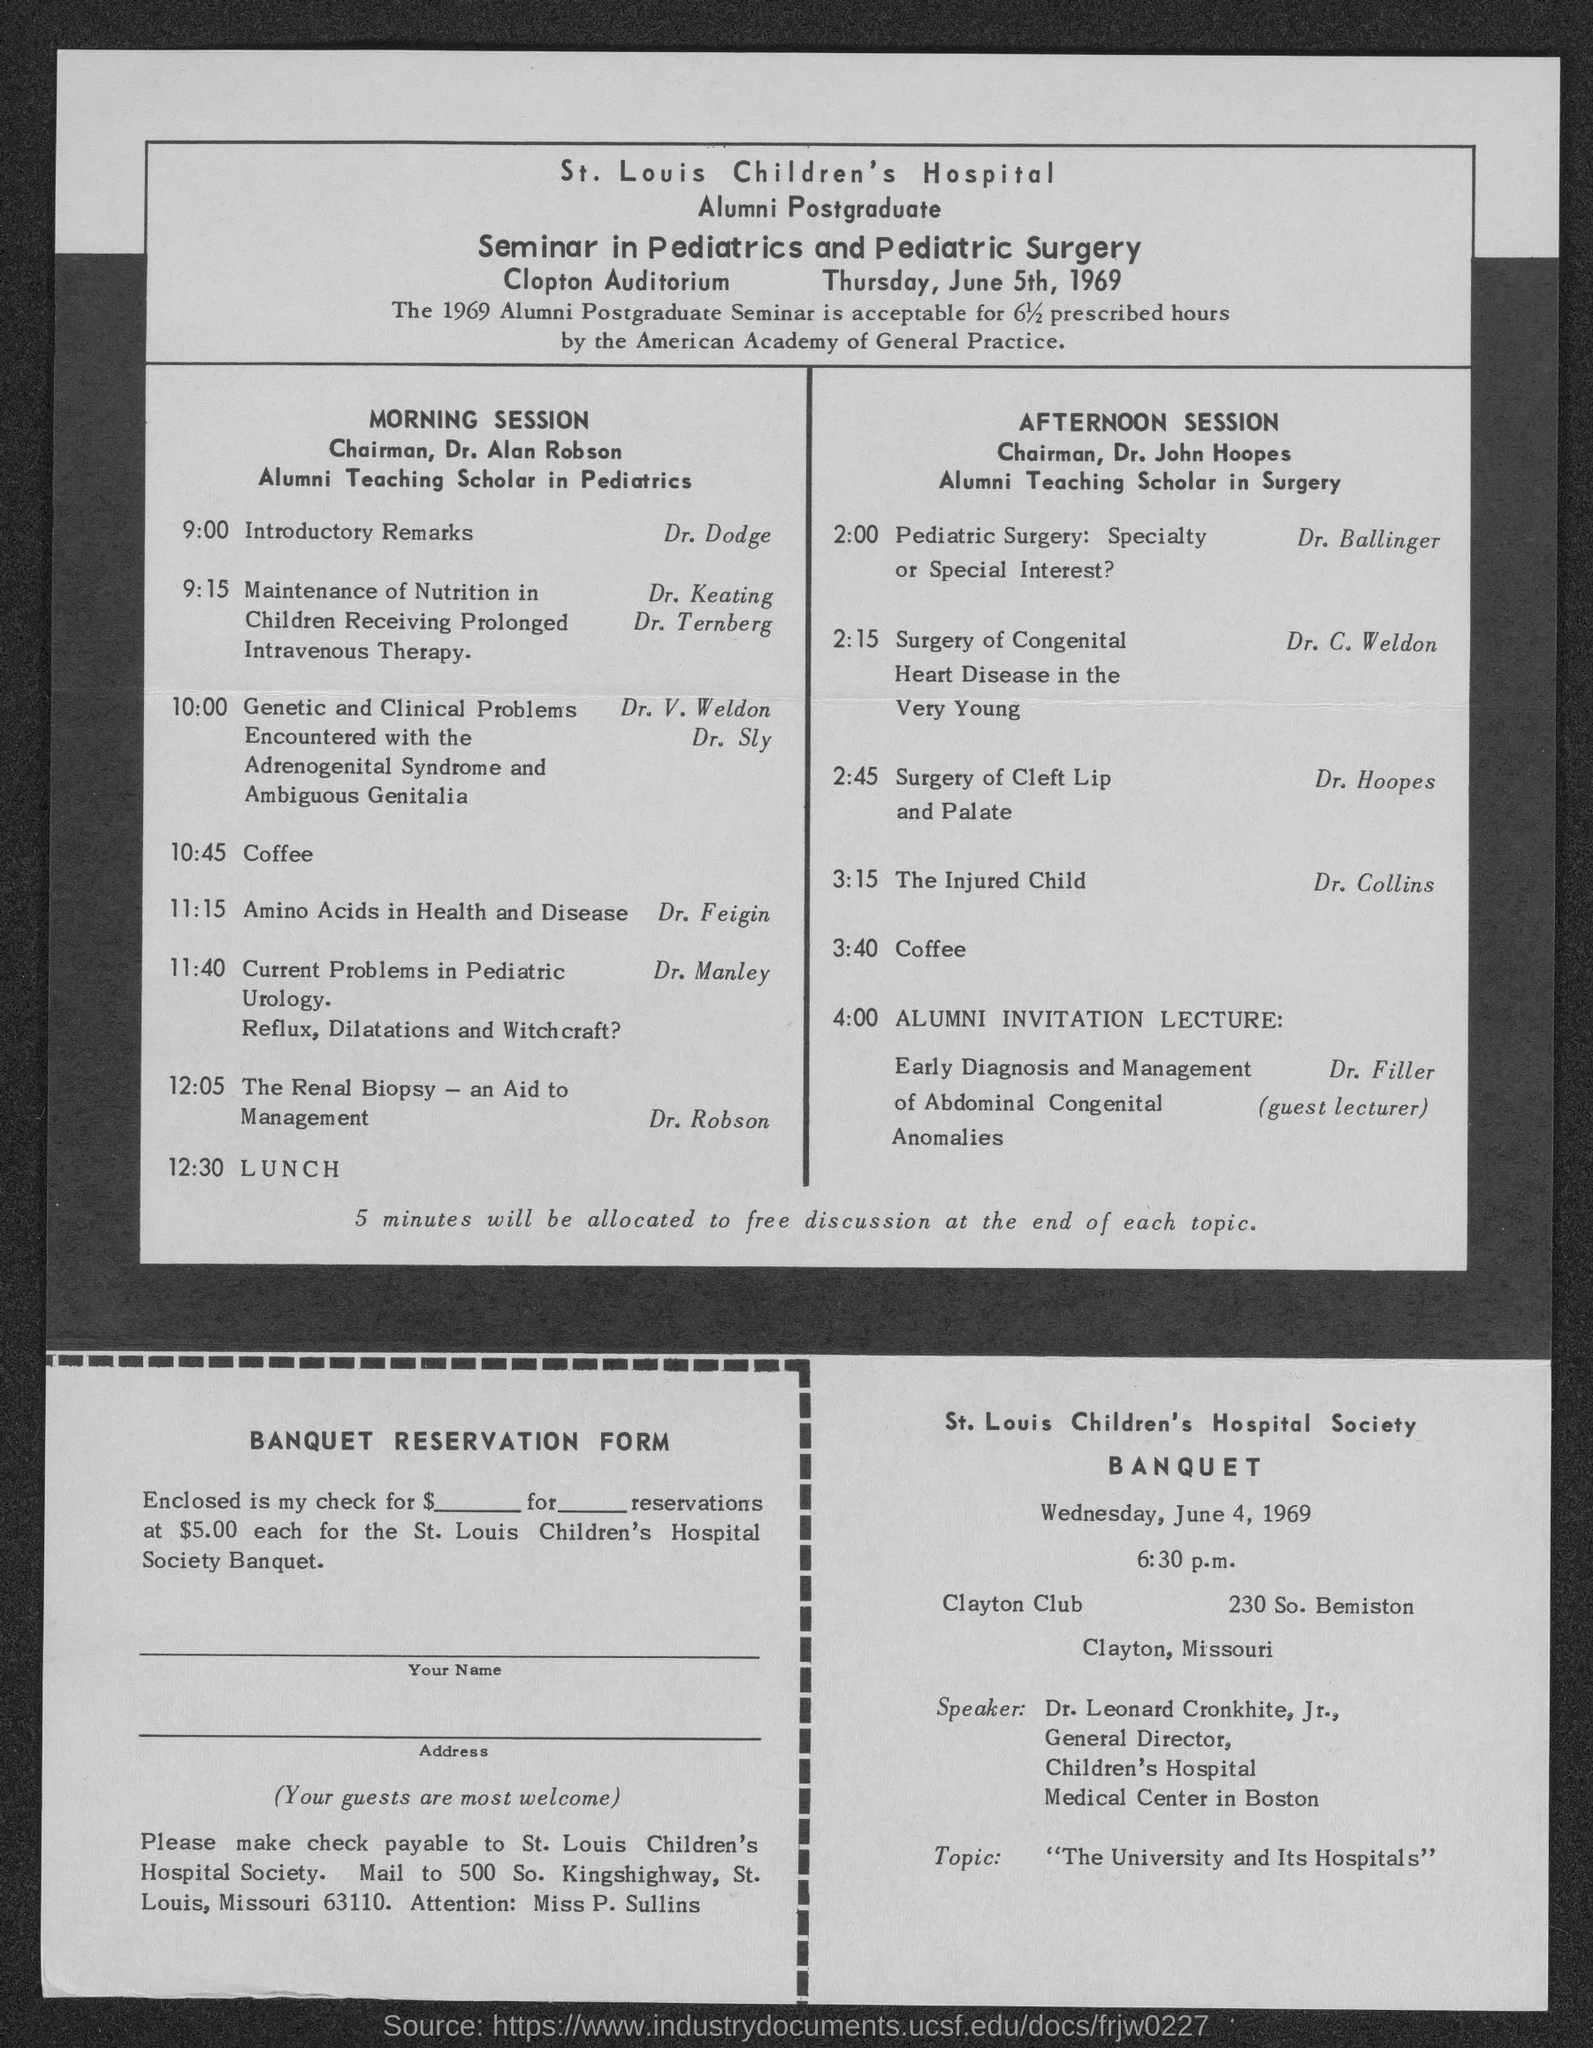Which hospital is mentioned?
Your response must be concise. St. Louis Children's Hospital. What is the seminar on?
Offer a very short reply. Seminar in Pediatrics and Pediatric Surgery. Where is the seminar going to be held?
Your response must be concise. Clopton auditorium. When is the seminar going to be held?
Your answer should be very brief. Thursday, June 5th, 1969. Who is the Chairman for morning session?
Provide a succinct answer. Dr. Alan Robson. Who is giving the introductory remarks?
Make the answer very short. Dr. Dodge. What is the topic of Dr. Feigin?
Keep it short and to the point. Amino Acids in Health and Disease. Who is talking on Surgery of Cleft Lip and Palate?
Keep it short and to the point. Dr. hoopes. When is the banquet going to be held?
Keep it short and to the point. Wednesday, June 4, 1969. To whom should check be payable?
Offer a very short reply. St. Louis Children's Hospital Society. 